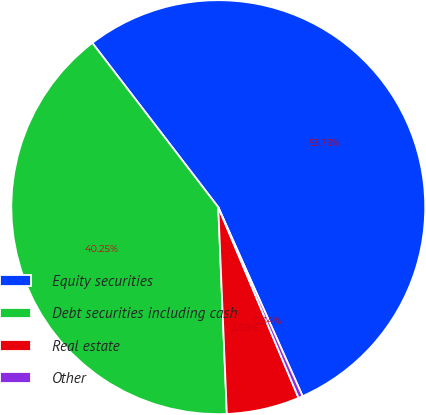<chart> <loc_0><loc_0><loc_500><loc_500><pie_chart><fcel>Equity securities<fcel>Debt securities including cash<fcel>Real estate<fcel>Other<nl><fcel>53.73%<fcel>40.25%<fcel>5.68%<fcel>0.34%<nl></chart> 